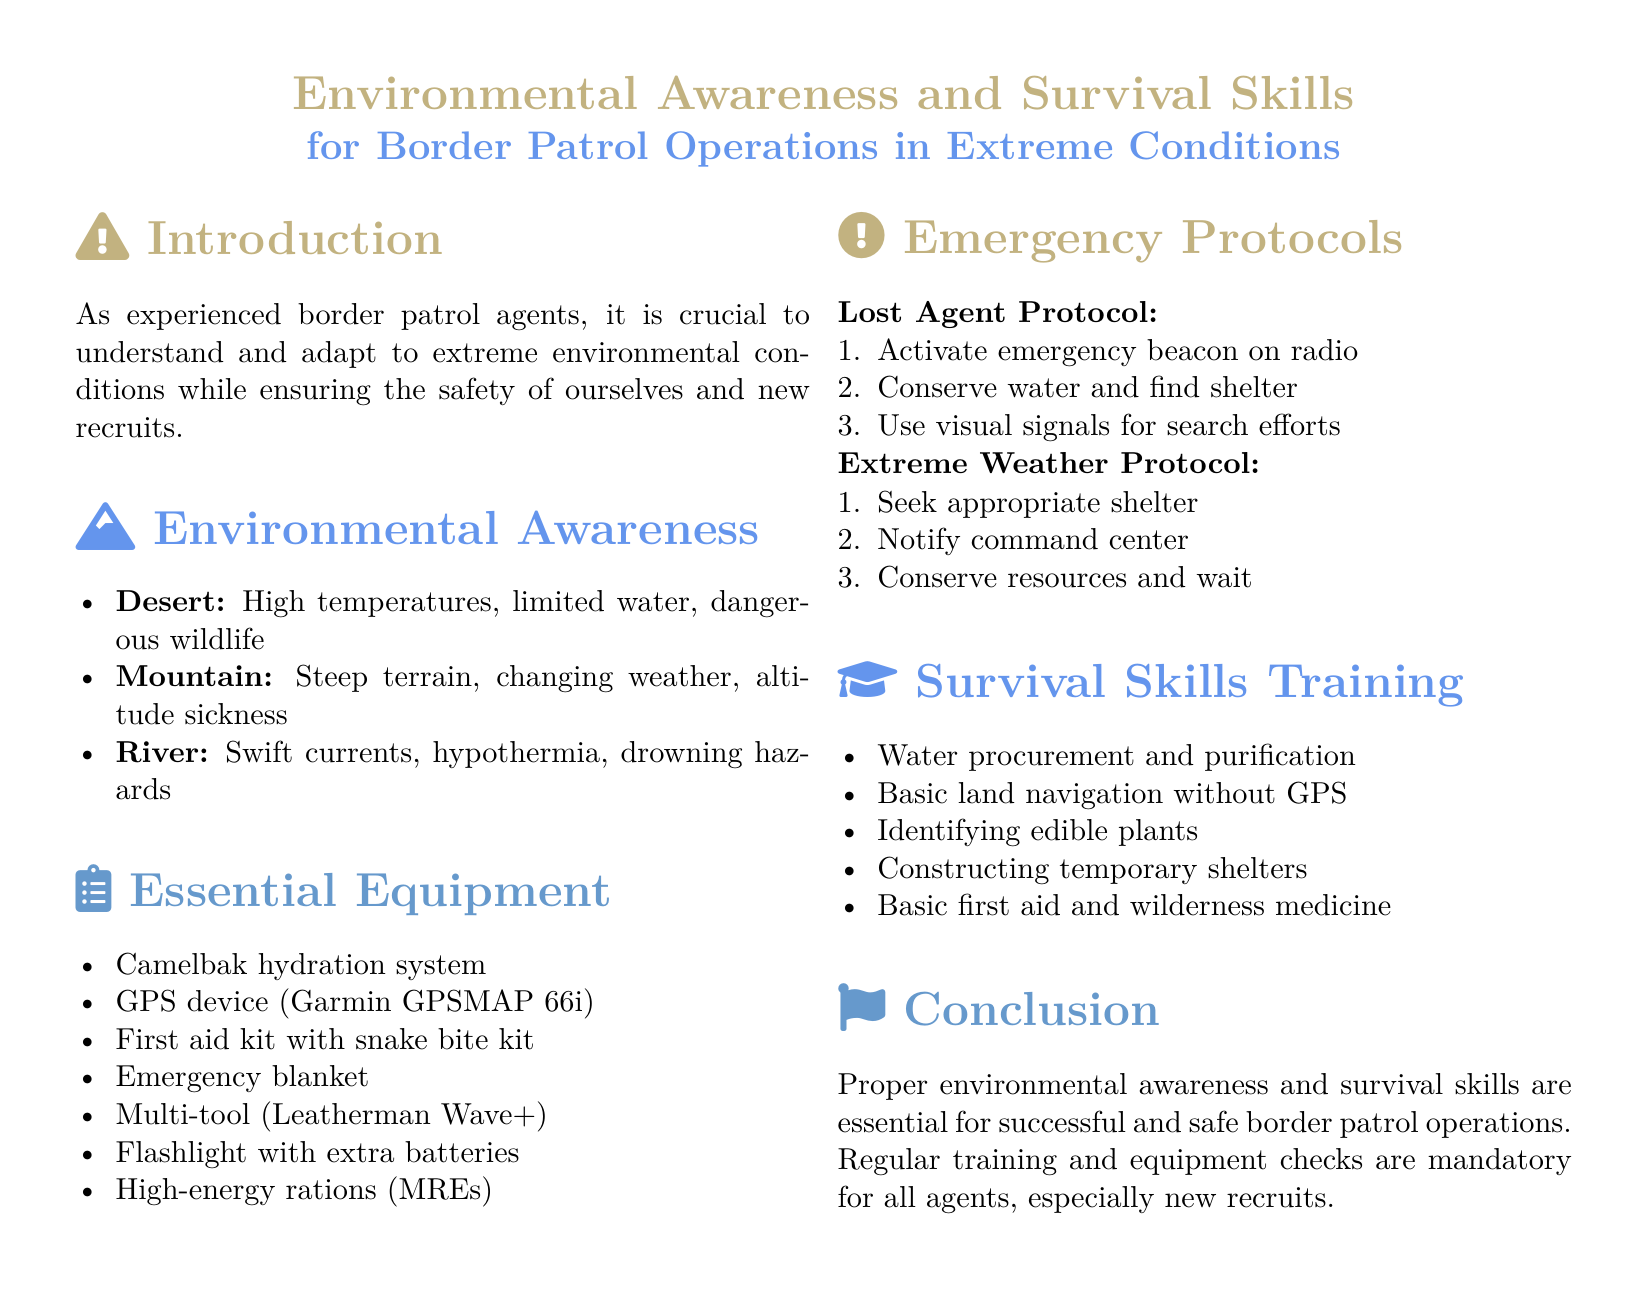What are the three environmental conditions mentioned? The document lists three environmental conditions: desert, mountain, and river.
Answer: desert, mountain, river What is the first item in the essential equipment list? The first item mentioned in the equipment list is the Camelbak hydration system.
Answer: Camelbak hydration system What should you activate if you are lost? The document states that you should activate the emergency beacon on the radio if lost.
Answer: emergency beacon What skill is related to identifying edible plants? The document lists identifying edible plants as part of survival skills training.
Answer: identifying edible plants How many steps are in the Lost Agent Protocol? The protocol consists of three steps as outlined in the document.
Answer: three steps What type of blanket should be included in the essential equipment? The document specifies that an emergency blanket is necessary equipment.
Answer: emergency blanket What does the Extreme Weather Protocol advise to do first? The first action advised is to seek appropriate shelter according to the protocol.
Answer: seek appropriate shelter What is mandatory for all agents, especially new recruits? Regular training and equipment checks are mentioned as mandatory in the document.
Answer: Regular training and equipment checks 